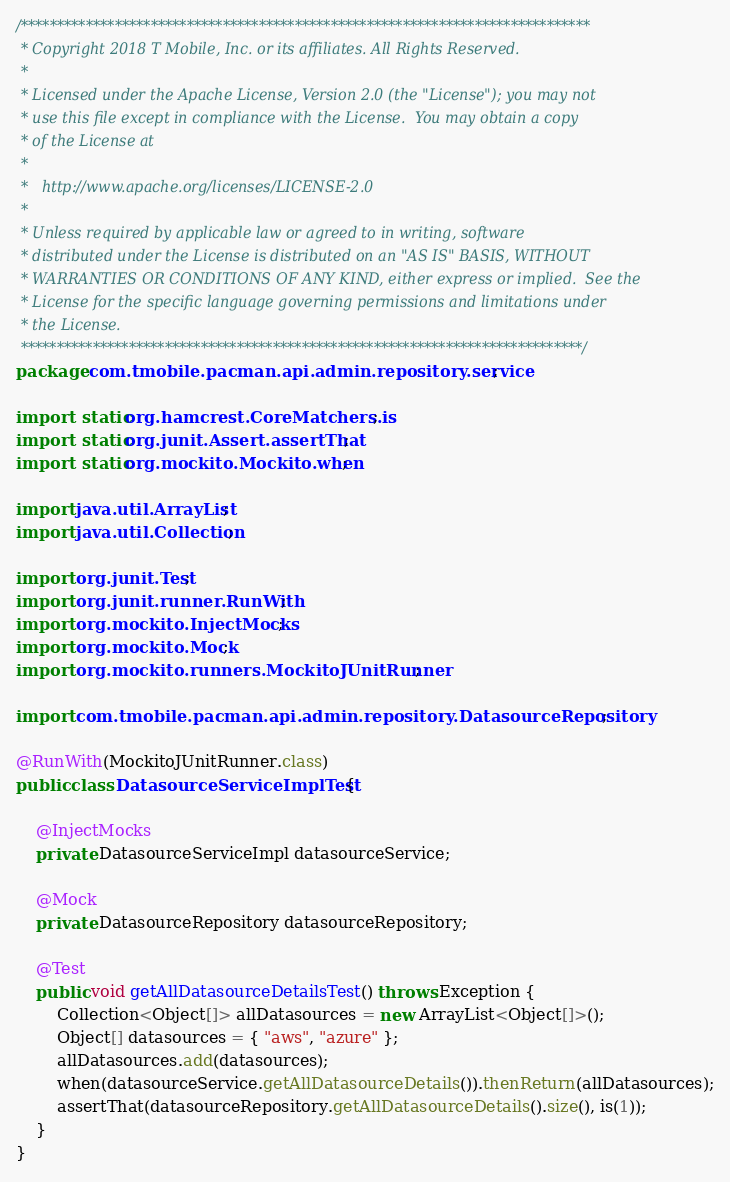Convert code to text. <code><loc_0><loc_0><loc_500><loc_500><_Java_>/*******************************************************************************
 * Copyright 2018 T Mobile, Inc. or its affiliates. All Rights Reserved.
 * 
 * Licensed under the Apache License, Version 2.0 (the "License"); you may not
 * use this file except in compliance with the License.  You may obtain a copy
 * of the License at
 * 
 *   http://www.apache.org/licenses/LICENSE-2.0
 * 
 * Unless required by applicable law or agreed to in writing, software
 * distributed under the License is distributed on an "AS IS" BASIS, WITHOUT
 * WARRANTIES OR CONDITIONS OF ANY KIND, either express or implied.  See the
 * License for the specific language governing permissions and limitations under
 * the License.
 ******************************************************************************/
package com.tmobile.pacman.api.admin.repository.service;

import static org.hamcrest.CoreMatchers.is;
import static org.junit.Assert.assertThat;
import static org.mockito.Mockito.when;

import java.util.ArrayList;
import java.util.Collection;

import org.junit.Test;
import org.junit.runner.RunWith;
import org.mockito.InjectMocks;
import org.mockito.Mock;
import org.mockito.runners.MockitoJUnitRunner;

import com.tmobile.pacman.api.admin.repository.DatasourceRepository;

@RunWith(MockitoJUnitRunner.class)
public class DatasourceServiceImplTest {

	@InjectMocks
	private DatasourceServiceImpl datasourceService;
	
	@Mock
	private DatasourceRepository datasourceRepository;

	@Test
	public void getAllDatasourceDetailsTest() throws Exception {
		Collection<Object[]> allDatasources = new ArrayList<Object[]>();
		Object[] datasources = { "aws", "azure" };
		allDatasources.add(datasources);
		when(datasourceService.getAllDatasourceDetails()).thenReturn(allDatasources);
		assertThat(datasourceRepository.getAllDatasourceDetails().size(), is(1));
	}
}
</code> 